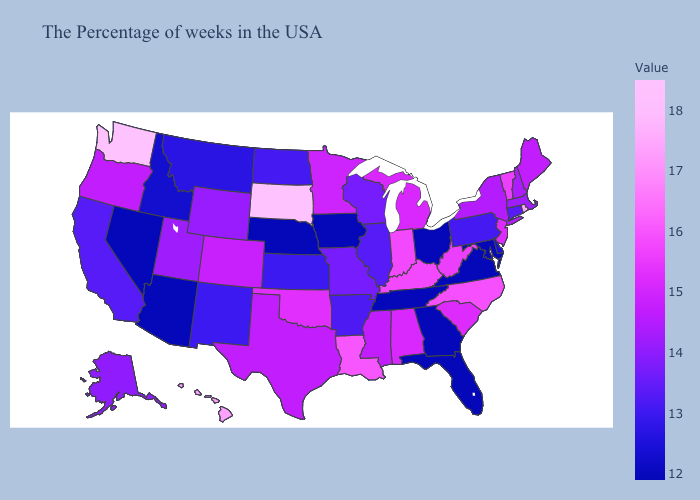Which states hav the highest value in the South?
Keep it brief. Louisiana. Does Arizona have the lowest value in the USA?
Concise answer only. Yes. Does Alaska have a higher value than Texas?
Be succinct. No. Among the states that border New York , which have the lowest value?
Keep it brief. Pennsylvania. Does the map have missing data?
Short answer required. No. Which states hav the highest value in the West?
Answer briefly. Washington. 